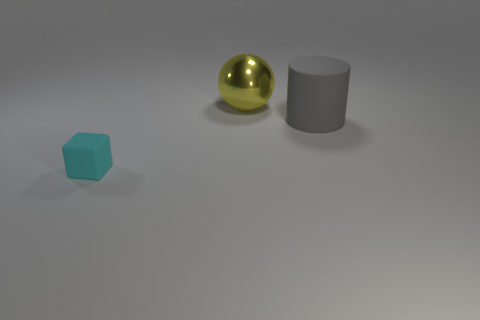Are there any other things that have the same size as the cyan cube?
Offer a terse response. No. How many matte things are either tiny cyan things or purple cylinders?
Offer a terse response. 1. What number of metallic spheres are to the right of the big thing that is left of the rubber object that is right of the large yellow metallic thing?
Give a very brief answer. 0. The cube that is the same material as the large cylinder is what size?
Keep it short and to the point. Small. How many things are the same color as the large sphere?
Give a very brief answer. 0. Is the size of the matte object behind the cyan matte thing the same as the big yellow object?
Your answer should be compact. Yes. The object that is to the right of the tiny matte block and in front of the sphere is what color?
Ensure brevity in your answer.  Gray. How many things are either gray cubes or rubber objects to the right of the large yellow metal sphere?
Keep it short and to the point. 1. What is the material of the big thing on the right side of the object that is behind the thing to the right of the big sphere?
Provide a succinct answer. Rubber. Are there any other things that are made of the same material as the big yellow sphere?
Give a very brief answer. No. 